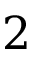Convert formula to latex. <formula><loc_0><loc_0><loc_500><loc_500>2</formula> 